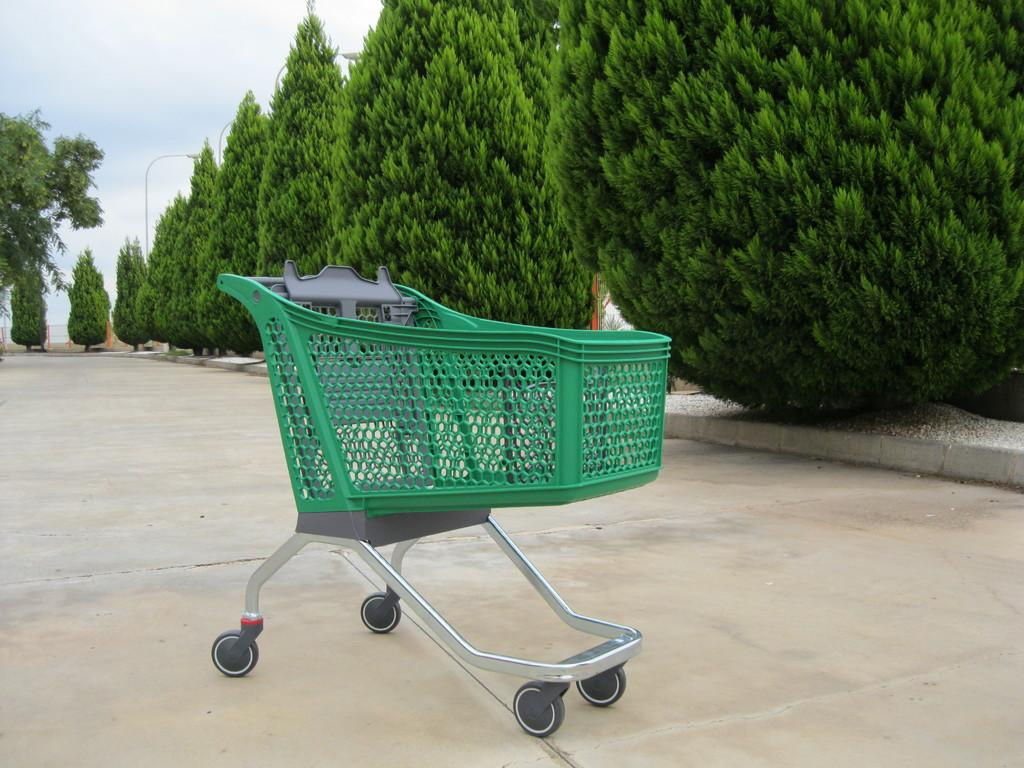What object is present on the ground in the image? There is a trolley placed on the ground in the image. What type of vegetation can be seen in the image? There is a group of trees in the image. What architectural feature is present in the image? There is a street pole in the image. What is visible in the sky in the image? The sky is visible in the image and appears cloudy. How many birds are in jail in the image? There are no birds or jails present in the image. What type of crook is visible in the image? There is no crook present in the image. 